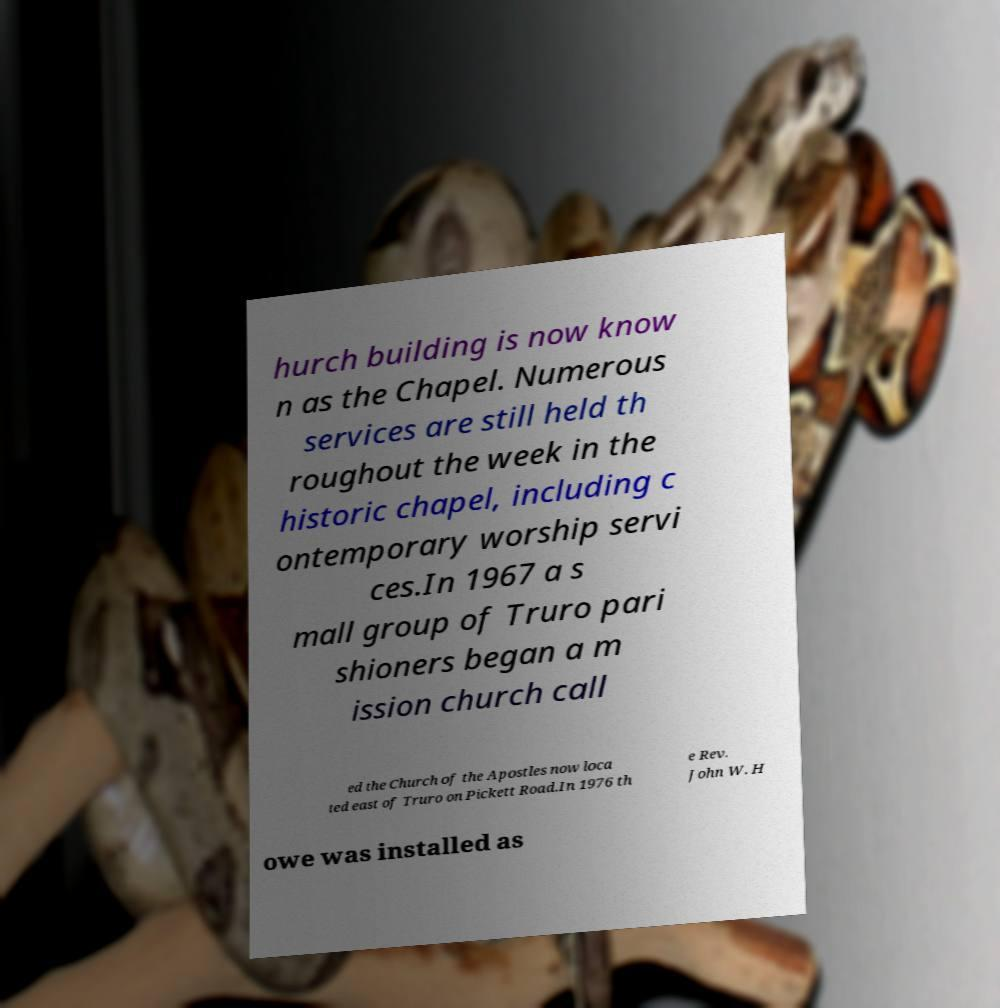What messages or text are displayed in this image? I need them in a readable, typed format. hurch building is now know n as the Chapel. Numerous services are still held th roughout the week in the historic chapel, including c ontemporary worship servi ces.In 1967 a s mall group of Truro pari shioners began a m ission church call ed the Church of the Apostles now loca ted east of Truro on Pickett Road.In 1976 th e Rev. John W. H owe was installed as 